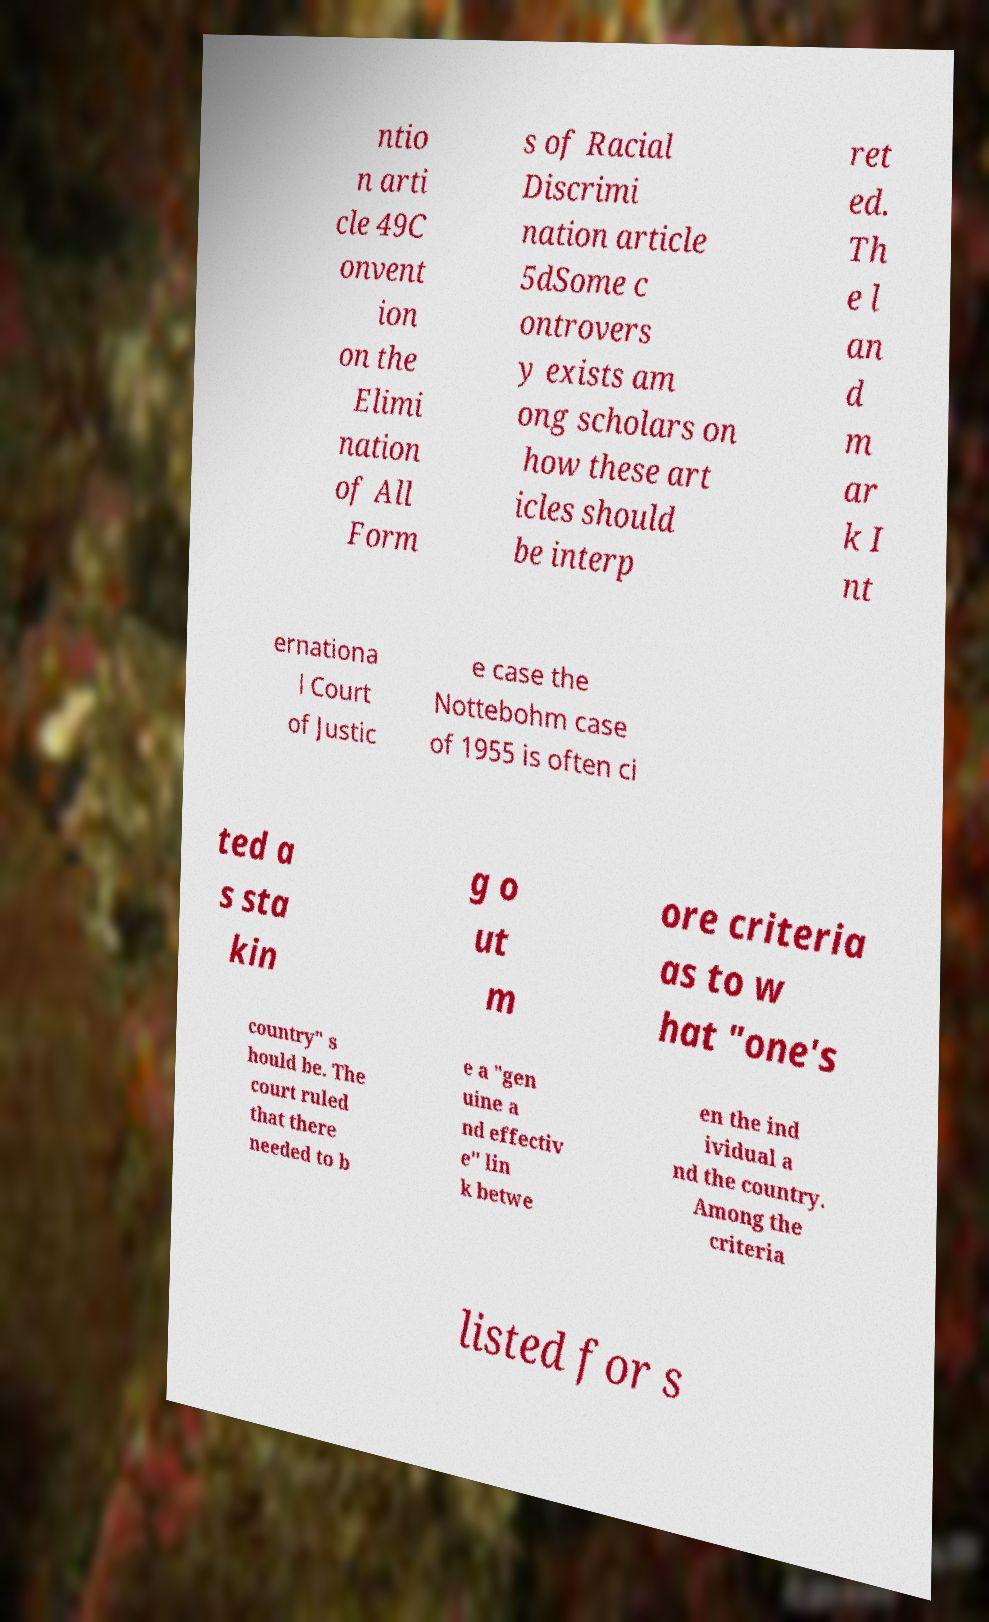For documentation purposes, I need the text within this image transcribed. Could you provide that? ntio n arti cle 49C onvent ion on the Elimi nation of All Form s of Racial Discrimi nation article 5dSome c ontrovers y exists am ong scholars on how these art icles should be interp ret ed. Th e l an d m ar k I nt ernationa l Court of Justic e case the Nottebohm case of 1955 is often ci ted a s sta kin g o ut m ore criteria as to w hat "one's country" s hould be. The court ruled that there needed to b e a "gen uine a nd effectiv e" lin k betwe en the ind ividual a nd the country. Among the criteria listed for s 